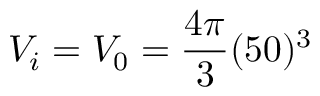Convert formula to latex. <formula><loc_0><loc_0><loc_500><loc_500>V _ { i } = V _ { 0 } = \frac { 4 \pi } { 3 } ( 5 0 ) ^ { 3 }</formula> 